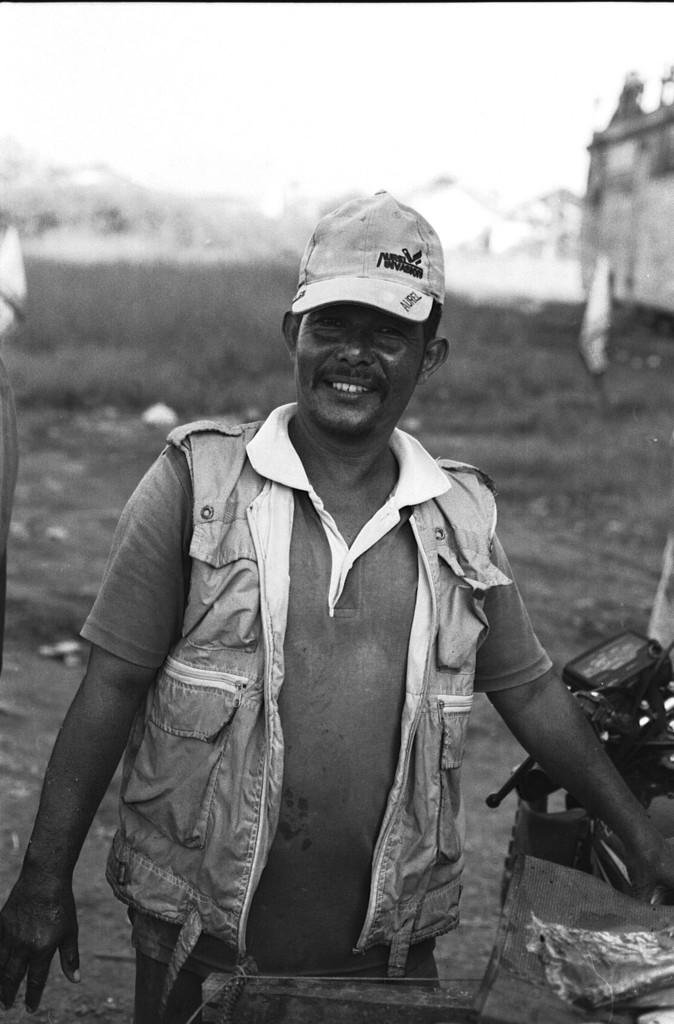Who is present in the image? There is a person in the image. What is the person wearing on their head? The person is wearing a cap. What is the person standing beside in the image? The person is standing beside a motor vehicle. What type of structure can be seen in the image? There is a building in the image. What type of vegetation is present in the image? There is grass in the image. What natural feature can be seen in the distance in the image? There are mountains covered with snow in the image. What suggestion does the person make to the mountains in the image? There is no suggestion made by the person to the mountains in the image, as the mountains are a natural feature and cannot engage in conversation or receive suggestions. 